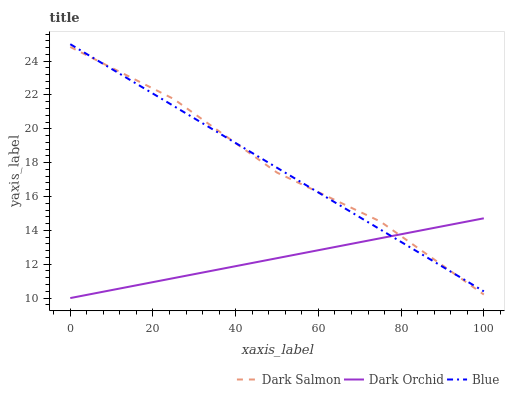Does Dark Orchid have the minimum area under the curve?
Answer yes or no. Yes. Does Dark Salmon have the maximum area under the curve?
Answer yes or no. Yes. Does Dark Salmon have the minimum area under the curve?
Answer yes or no. No. Does Dark Orchid have the maximum area under the curve?
Answer yes or no. No. Is Dark Orchid the smoothest?
Answer yes or no. Yes. Is Dark Salmon the roughest?
Answer yes or no. Yes. Is Dark Salmon the smoothest?
Answer yes or no. No. Is Dark Orchid the roughest?
Answer yes or no. No. Does Dark Orchid have the lowest value?
Answer yes or no. Yes. Does Dark Salmon have the lowest value?
Answer yes or no. No. Does Blue have the highest value?
Answer yes or no. Yes. Does Dark Salmon have the highest value?
Answer yes or no. No. Does Blue intersect Dark Orchid?
Answer yes or no. Yes. Is Blue less than Dark Orchid?
Answer yes or no. No. Is Blue greater than Dark Orchid?
Answer yes or no. No. 